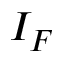Convert formula to latex. <formula><loc_0><loc_0><loc_500><loc_500>I _ { F }</formula> 